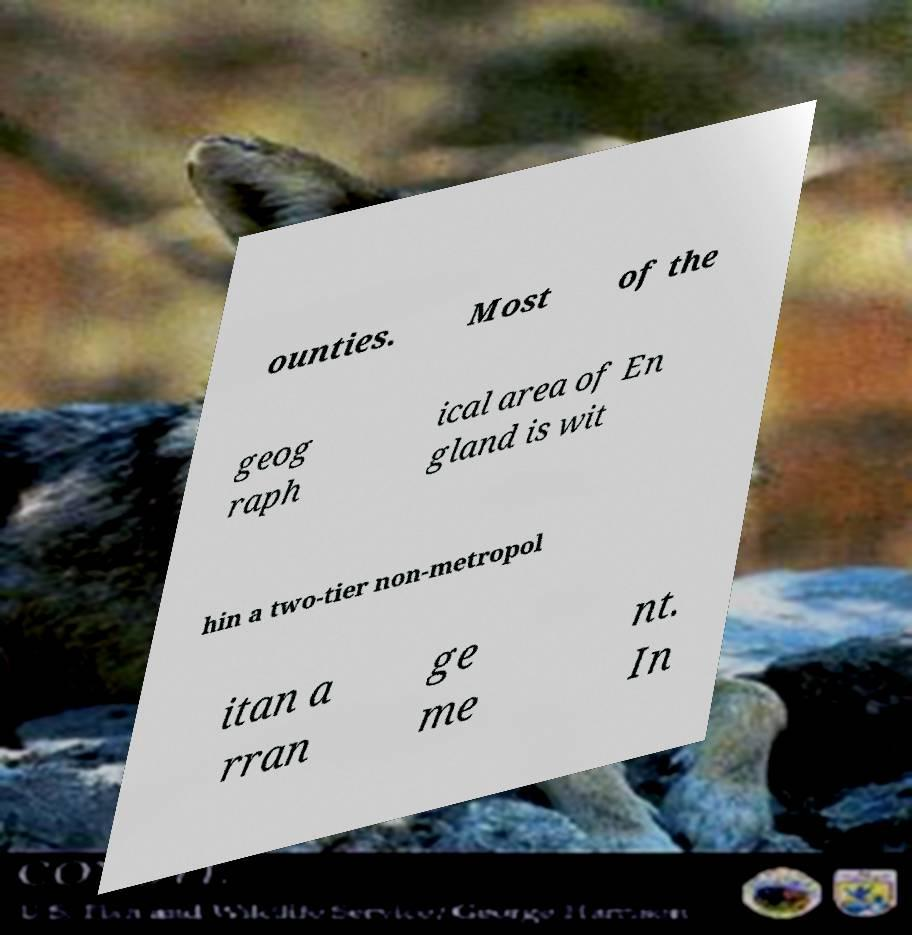Please read and relay the text visible in this image. What does it say? ounties. Most of the geog raph ical area of En gland is wit hin a two-tier non-metropol itan a rran ge me nt. In 